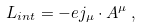<formula> <loc_0><loc_0><loc_500><loc_500>L _ { i n t } = - e j _ { \mu } \cdot A ^ { \mu } \, ,</formula> 